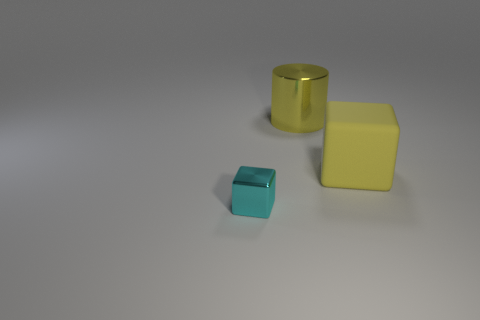Subtract all blue blocks. Subtract all brown cylinders. How many blocks are left? 2 Add 2 large cyan cylinders. How many objects exist? 5 Subtract all cylinders. How many objects are left? 2 Subtract 1 yellow cylinders. How many objects are left? 2 Subtract all gray blocks. Subtract all large yellow shiny objects. How many objects are left? 2 Add 1 big objects. How many big objects are left? 3 Add 3 cyan metal things. How many cyan metal things exist? 4 